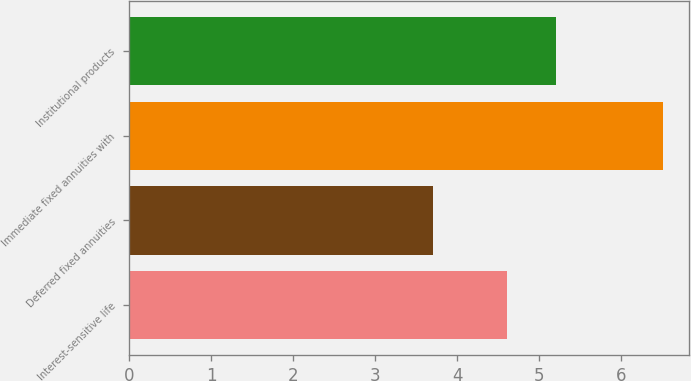Convert chart. <chart><loc_0><loc_0><loc_500><loc_500><bar_chart><fcel>Interest-sensitive life<fcel>Deferred fixed annuities<fcel>Immediate fixed annuities with<fcel>Institutional products<nl><fcel>4.6<fcel>3.7<fcel>6.5<fcel>5.2<nl></chart> 